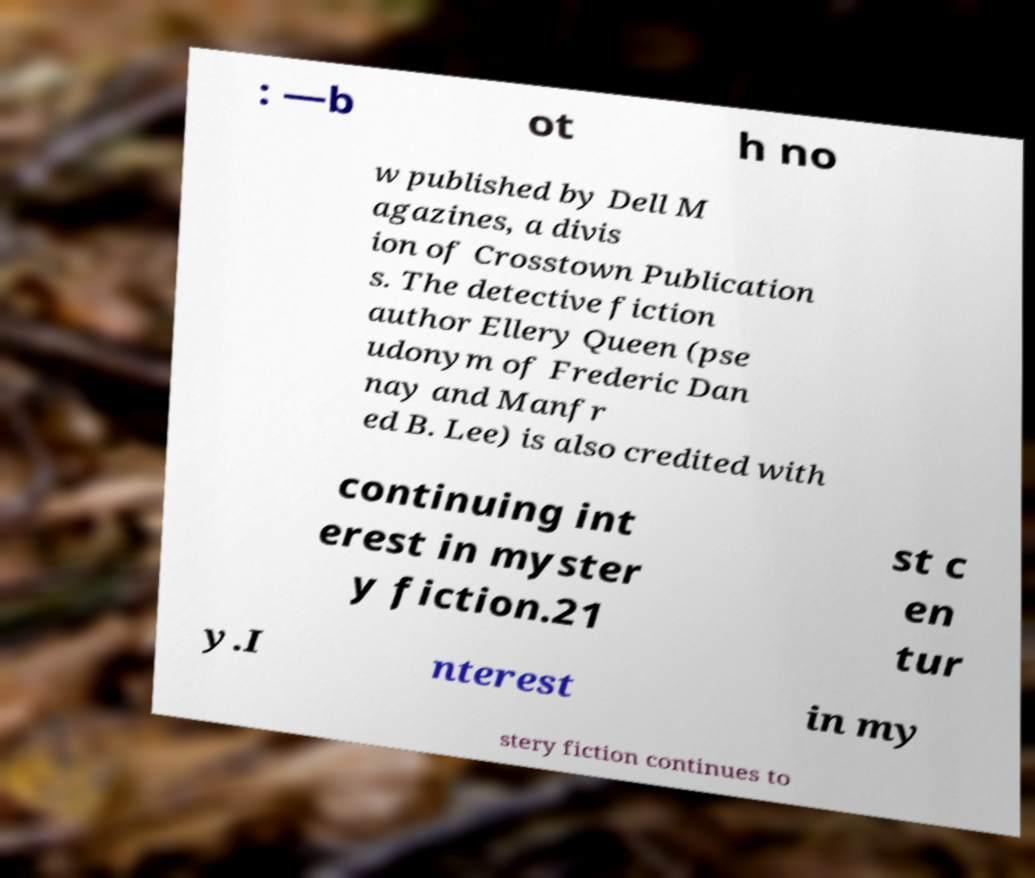There's text embedded in this image that I need extracted. Can you transcribe it verbatim? : —b ot h no w published by Dell M agazines, a divis ion of Crosstown Publication s. The detective fiction author Ellery Queen (pse udonym of Frederic Dan nay and Manfr ed B. Lee) is also credited with continuing int erest in myster y fiction.21 st c en tur y.I nterest in my stery fiction continues to 